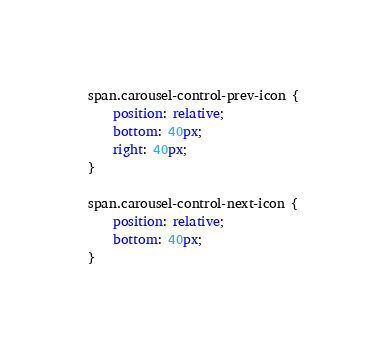Convert code to text. <code><loc_0><loc_0><loc_500><loc_500><_CSS_>span.carousel-control-prev-icon {
    position: relative;
    bottom: 40px;
    right: 40px;
}

span.carousel-control-next-icon {
    position: relative;
    bottom: 40px;
}
</code> 